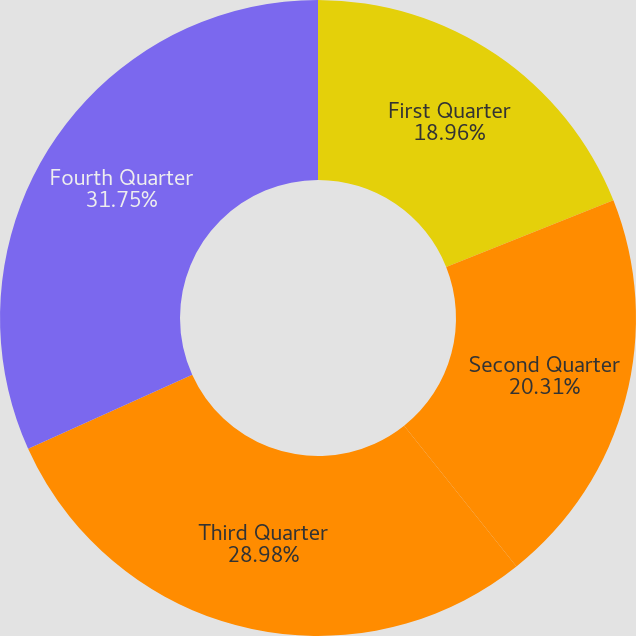<chart> <loc_0><loc_0><loc_500><loc_500><pie_chart><fcel>First Quarter<fcel>Second Quarter<fcel>Third Quarter<fcel>Fourth Quarter<nl><fcel>18.96%<fcel>20.31%<fcel>28.98%<fcel>31.74%<nl></chart> 